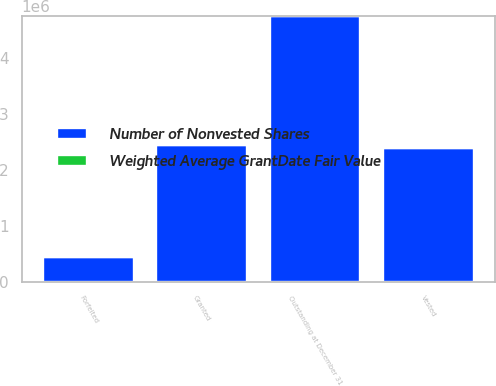<chart> <loc_0><loc_0><loc_500><loc_500><stacked_bar_chart><ecel><fcel>Outstanding at December 31<fcel>Granted<fcel>Vested<fcel>Forfeited<nl><fcel>Number of Nonvested Shares<fcel>4.75838e+06<fcel>2.45249e+06<fcel>2.39284e+06<fcel>446985<nl><fcel>Weighted Average GrantDate Fair Value<fcel>8.94<fcel>9.33<fcel>7.9<fcel>8.9<nl></chart> 